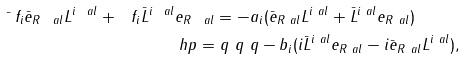<formula> <loc_0><loc_0><loc_500><loc_500>\bar { \ } f _ { i } \bar { e } _ { R \ a l } L ^ { i \ a l } + \ f _ { i } \bar { L } ^ { i \ a l } e _ { R \ a l } & = - a _ { i } ( \bar { e } _ { R \ a l } L ^ { i \ a l } + \bar { L } ^ { i \ a l } e _ { R \ a l } ) \\ \ h p = & \ q \ q \ q - b _ { i } ( i \bar { L } ^ { i \ a l } e _ { R \ a l } - i \bar { e } _ { R \ a l } L ^ { i \ a l } ) ,</formula> 